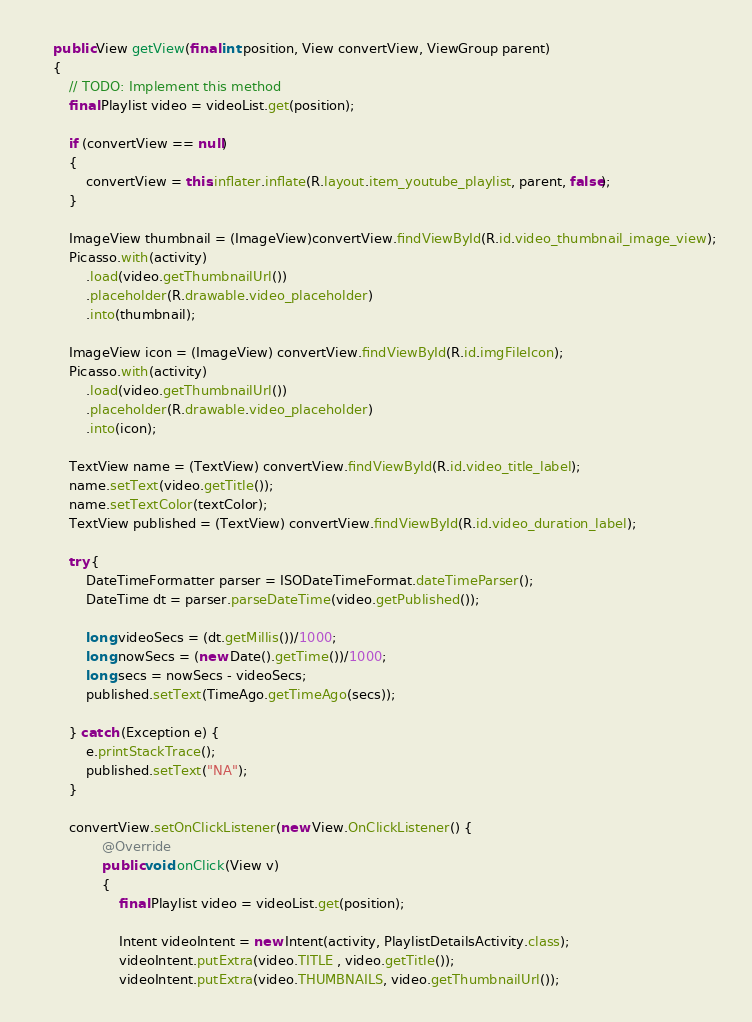Convert code to text. <code><loc_0><loc_0><loc_500><loc_500><_Java_>	public View getView(final int position, View convertView, ViewGroup parent)
	{
		// TODO: Implement this method
		final Playlist video = videoList.get(position);

		if (convertView == null)
		{
            convertView = this.inflater.inflate(R.layout.item_youtube_playlist, parent, false);
		}

		ImageView thumbnail = (ImageView)convertView.findViewById(R.id.video_thumbnail_image_view);
		Picasso.with(activity)
			.load(video.getThumbnailUrl())
			.placeholder(R.drawable.video_placeholder)
			.into(thumbnail);

		ImageView icon = (ImageView) convertView.findViewById(R.id.imgFileIcon);
		Picasso.with(activity)
			.load(video.getThumbnailUrl())
			.placeholder(R.drawable.video_placeholder)
			.into(icon);

		TextView name = (TextView) convertView.findViewById(R.id.video_title_label);
		name.setText(video.getTitle());	
		name.setTextColor(textColor);
		TextView published = (TextView) convertView.findViewById(R.id.video_duration_label);       
		
		try {
            DateTimeFormatter parser = ISODateTimeFormat.dateTimeParser();
            DateTime dt = parser.parseDateTime(video.getPublished());

            long videoSecs = (dt.getMillis())/1000;
            long nowSecs = (new Date().getTime())/1000;
            long secs = nowSecs - videoSecs;
            published.setText(TimeAgo.getTimeAgo(secs));
			
        } catch (Exception e) {
            e.printStackTrace();
            published.setText("NA");
        } 
		
		convertView.setOnClickListener(new View.OnClickListener() {
				@Override
				public void onClick(View v)
				{
					final Playlist video = videoList.get(position);

					Intent videoIntent = new Intent(activity, PlaylistDetailsActivity.class);
					videoIntent.putExtra(video.TITLE , video.getTitle());
					videoIntent.putExtra(video.THUMBNAILS, video.getThumbnailUrl());</code> 